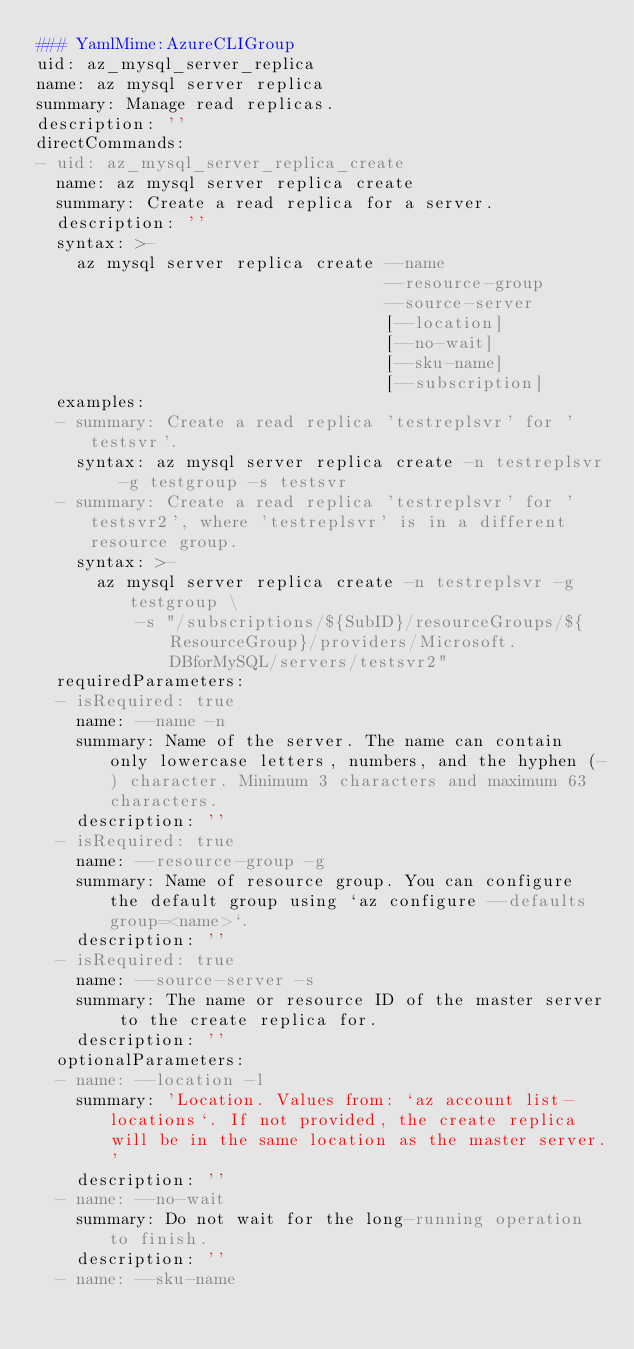<code> <loc_0><loc_0><loc_500><loc_500><_YAML_>### YamlMime:AzureCLIGroup
uid: az_mysql_server_replica
name: az mysql server replica
summary: Manage read replicas.
description: ''
directCommands:
- uid: az_mysql_server_replica_create
  name: az mysql server replica create
  summary: Create a read replica for a server.
  description: ''
  syntax: >-
    az mysql server replica create --name
                                   --resource-group
                                   --source-server
                                   [--location]
                                   [--no-wait]
                                   [--sku-name]
                                   [--subscription]
  examples:
  - summary: Create a read replica 'testreplsvr' for 'testsvr'.
    syntax: az mysql server replica create -n testreplsvr -g testgroup -s testsvr
  - summary: Create a read replica 'testreplsvr' for 'testsvr2', where 'testreplsvr' is in a different resource group.
    syntax: >-
      az mysql server replica create -n testreplsvr -g testgroup \
          -s "/subscriptions/${SubID}/resourceGroups/${ResourceGroup}/providers/Microsoft.DBforMySQL/servers/testsvr2"
  requiredParameters:
  - isRequired: true
    name: --name -n
    summary: Name of the server. The name can contain only lowercase letters, numbers, and the hyphen (-) character. Minimum 3 characters and maximum 63 characters.
    description: ''
  - isRequired: true
    name: --resource-group -g
    summary: Name of resource group. You can configure the default group using `az configure --defaults group=<name>`.
    description: ''
  - isRequired: true
    name: --source-server -s
    summary: The name or resource ID of the master server to the create replica for.
    description: ''
  optionalParameters:
  - name: --location -l
    summary: 'Location. Values from: `az account list-locations`. If not provided, the create replica will be in the same location as the master server.'
    description: ''
  - name: --no-wait
    summary: Do not wait for the long-running operation to finish.
    description: ''
  - name: --sku-name</code> 